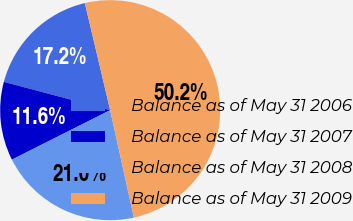Convert chart to OTSL. <chart><loc_0><loc_0><loc_500><loc_500><pie_chart><fcel>Balance as of May 31 2006<fcel>Balance as of May 31 2007<fcel>Balance as of May 31 2008<fcel>Balance as of May 31 2009<nl><fcel>17.16%<fcel>11.57%<fcel>21.03%<fcel>50.24%<nl></chart> 